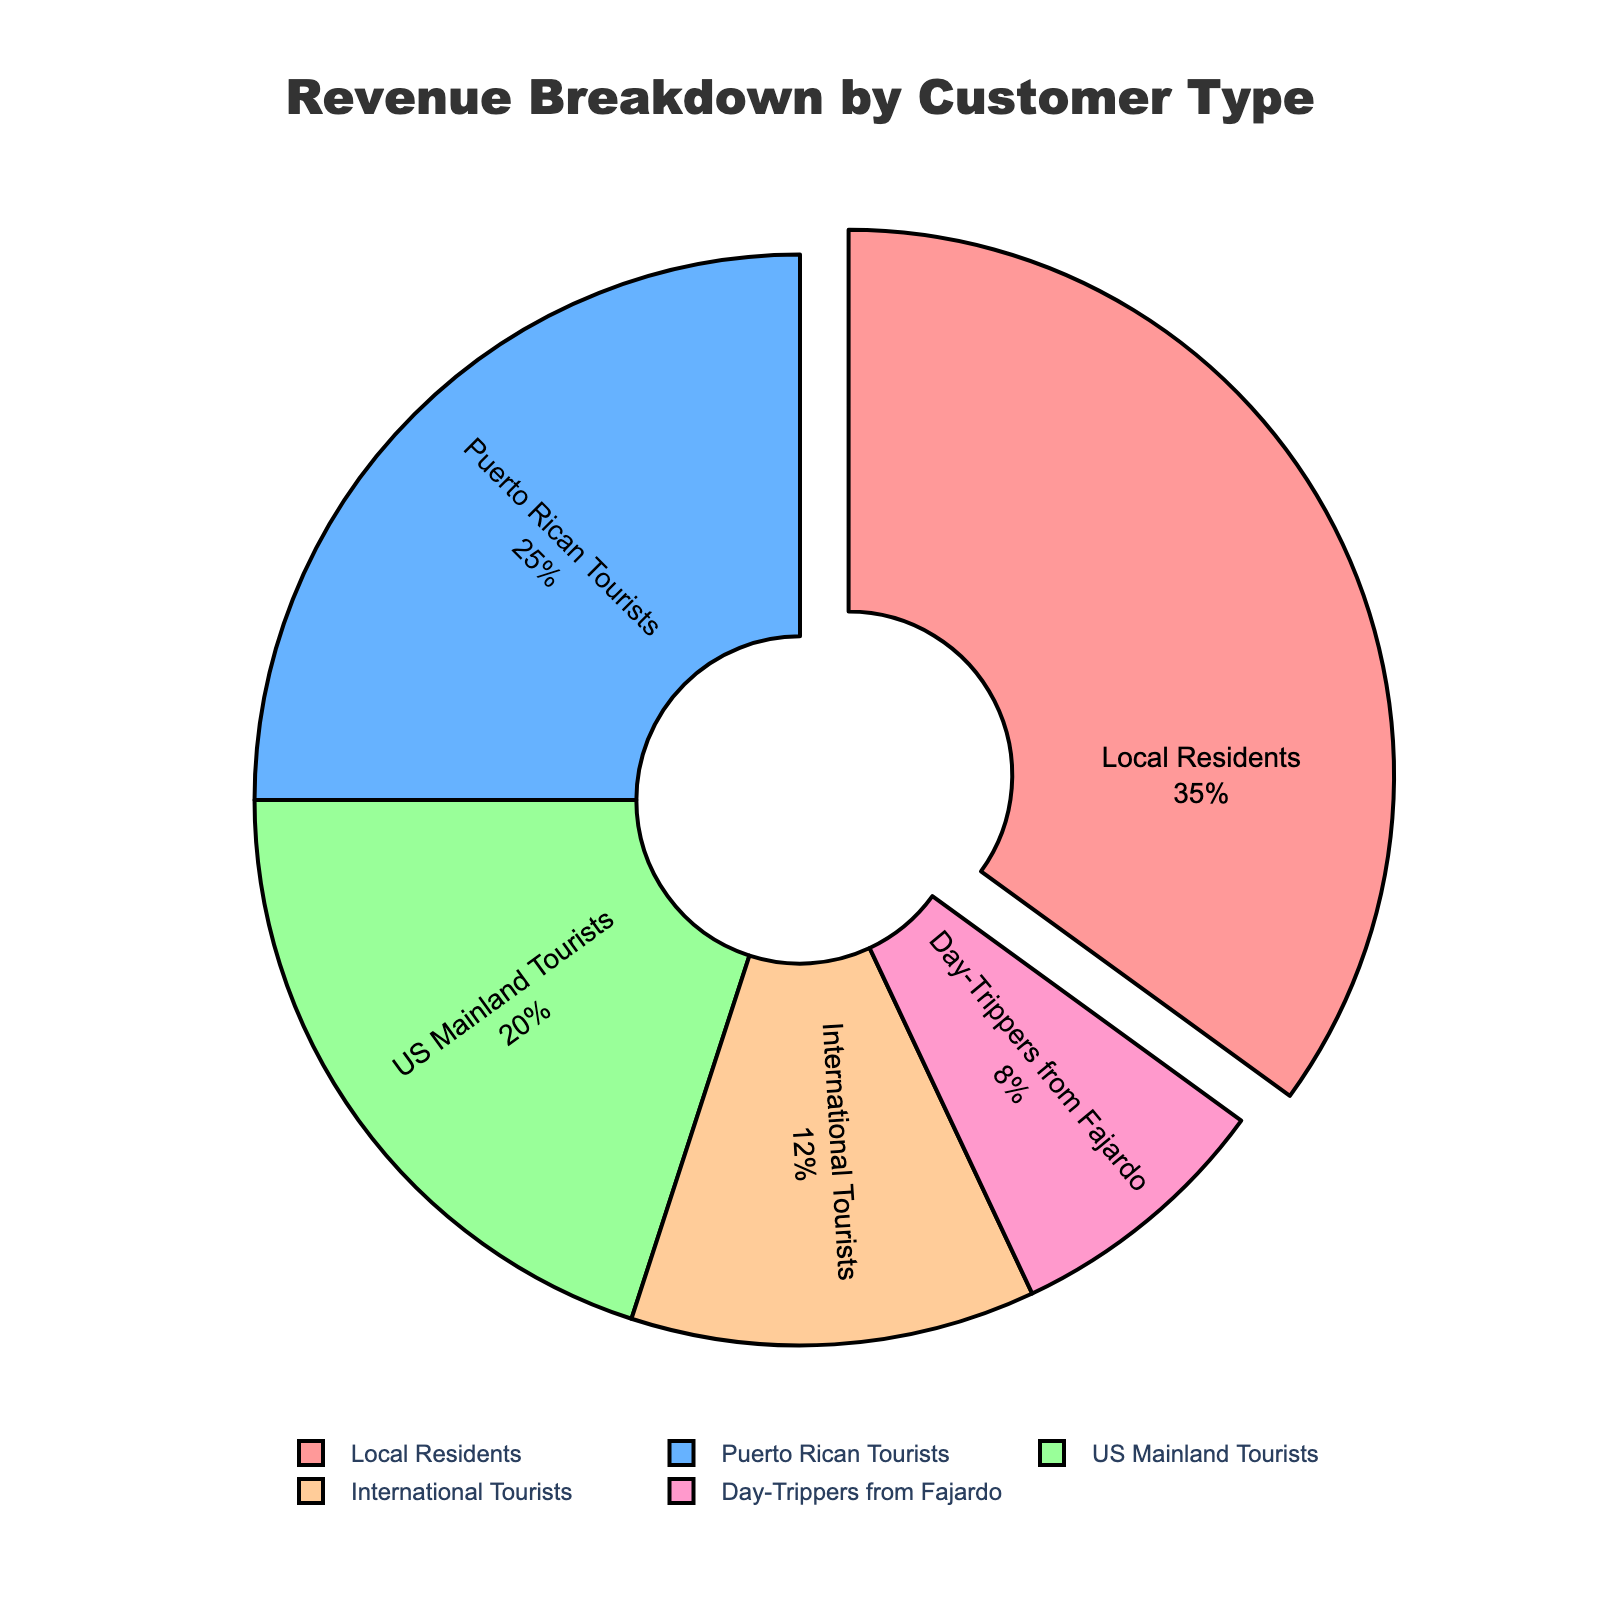What percentage of revenue is generated by tourists (both Puerto Rican and International)? To find the percentage of revenue generated by tourists, you need to sum the percentages for Puerto Rican Tourists and International Tourists. Puerto Rican Tourists contribute 25% and International Tourists contribute 12%, so the total is 25% + 12% = 37%
Answer: 37% Which customer type generates the highest percentage of revenue? To determine which customer type generates the highest percentage of revenue, look for the largest percentage segment in the pie chart. Local Residents account for 35%, which is higher than any other group.
Answer: Local Residents Which customer types combined generate more revenue than Puerto Rican Tourists? Puerto Rican Tourists generate 25%. Add the percentages of other customer types and compare: Local Residents (35%), US Mainland Tourists (20%), International Tourists (12%), and Day-Trippers from Fajardo (8%). Local Residents alone (35%) generate more revenue than Puerto Rican Tourists (25%).
Answer: Local Residents What is the combined revenue percentage of Local Residents and Day-Trippers from Fajardo? To find the combined revenue percentage of Local Residents and Day-Trippers from Fajardo, simply add the two percentages: Local Residents (35%) + Day-Trippers from Fajardo (8%) = 43%
Answer: 43% Which is greater: the revenue from US Mainland Tourists or International Tourists? To compare the revenue generated by US Mainland Tourists and International Tourists, look at their percentages: US Mainland Tourists generate 20% and International Tourists generate 12%. Therefore, US Mainland Tourists generate more revenue.
Answer: US Mainland Tourists What is the difference in revenue percentage between Local Residents and US Mainland Tourists? To find the difference in revenue percentage between Local Residents and US Mainland Tourists, subtract the percentage of US Mainland Tourists from Local Residents: 35% - 20% = 15%
Answer: 15% If another customer type was added with a revenue percentage of 10%, how would this affect the combined revenue percentage of all tourists (Puerto Rican, US Mainland, and International)? First, calculate the current combined revenue percentage of all tourists: Puerto Rican Tourists (25%) + US Mainland Tourists (20%) + International Tourists (12%) = 57%. Adding another customer type with 10% increases the total revenue to 110%, so the new combined percentage for all tourists is (57% / 110%) * 100% = 51.82% approximately.
Answer: 51.82% What visual attribute distinguishes the segment representing Local Residents? The Local Residents segment is pulled out slightly from the pie chart, which visually distinguishes it from the other segments.
Answer: It is pulled out Which segment of the pie chart has the smallest percentage? The segment with the smallest percentage will have the smallest arc length and area. In this case, Day-Trippers from Fajardo, which contribute 8%, is the smallest segment.
Answer: Day-Trippers from Fajardo 